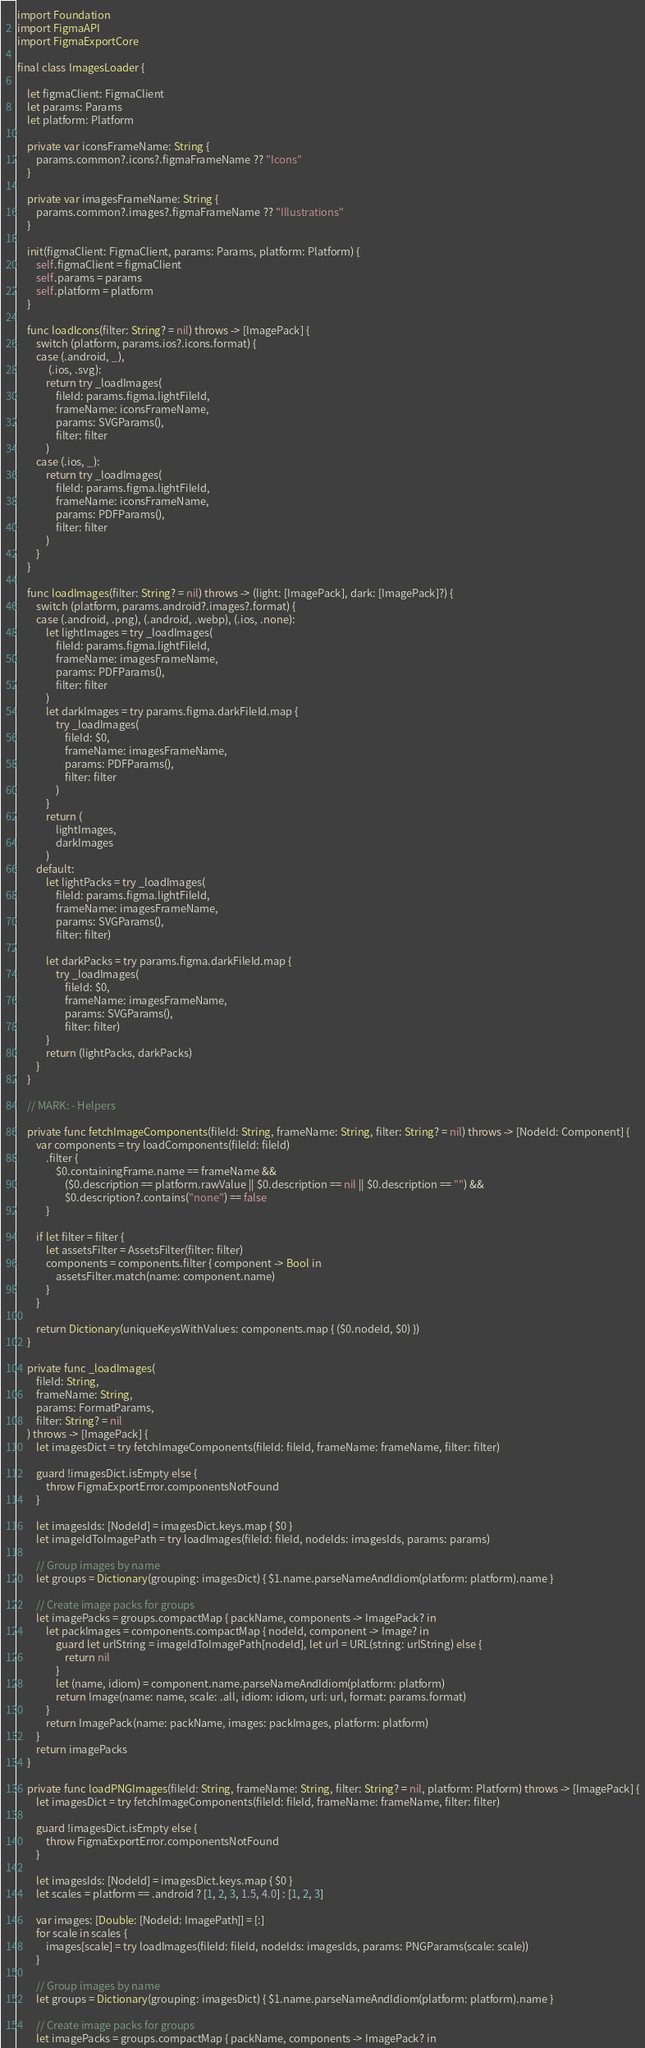<code> <loc_0><loc_0><loc_500><loc_500><_Swift_>import Foundation
import FigmaAPI
import FigmaExportCore

final class ImagesLoader {

    let figmaClient: FigmaClient
    let params: Params
    let platform: Platform
    
    private var iconsFrameName: String {
        params.common?.icons?.figmaFrameName ?? "Icons"
    }
    
    private var imagesFrameName: String {
        params.common?.images?.figmaFrameName ?? "Illustrations"
    }
    
    init(figmaClient: FigmaClient, params: Params, platform: Platform) {
        self.figmaClient = figmaClient
        self.params = params
        self.platform = platform
    }

    func loadIcons(filter: String? = nil) throws -> [ImagePack] {
        switch (platform, params.ios?.icons.format) {
        case (.android, _),
             (.ios, .svg):
            return try _loadImages(
                fileId: params.figma.lightFileId,
                frameName: iconsFrameName,
                params: SVGParams(),
                filter: filter
            )
        case (.ios, _):
            return try _loadImages(
                fileId: params.figma.lightFileId,
                frameName: iconsFrameName,
                params: PDFParams(),
                filter: filter
            )
        }
    }

    func loadImages(filter: String? = nil) throws -> (light: [ImagePack], dark: [ImagePack]?) {
        switch (platform, params.android?.images?.format) {
        case (.android, .png), (.android, .webp), (.ios, .none):
            let lightImages = try _loadImages(
                fileId: params.figma.lightFileId,
                frameName: imagesFrameName,
                params: PDFParams(),
                filter: filter
            )
            let darkImages = try params.figma.darkFileId.map {
                try _loadImages(
                    fileId: $0,
                    frameName: imagesFrameName,
                    params: PDFParams(),
                    filter: filter
                )
            }
            return (
                lightImages,
                darkImages
            )
        default:
            let lightPacks = try _loadImages(
                fileId: params.figma.lightFileId,
                frameName: imagesFrameName,
                params: SVGParams(),
                filter: filter)
            
            let darkPacks = try params.figma.darkFileId.map {
                try _loadImages(
                    fileId: $0,
                    frameName: imagesFrameName,
                    params: SVGParams(),
                    filter: filter)
            }
            return (lightPacks, darkPacks)
        }
    }

    // MARK: - Helpers

    private func fetchImageComponents(fileId: String, frameName: String, filter: String? = nil) throws -> [NodeId: Component] {
        var components = try loadComponents(fileId: fileId)
            .filter {
                $0.containingFrame.name == frameName &&
                    ($0.description == platform.rawValue || $0.description == nil || $0.description == "") &&
                    $0.description?.contains("none") == false
            }
        
        if let filter = filter {
            let assetsFilter = AssetsFilter(filter: filter)
            components = components.filter { component -> Bool in
                assetsFilter.match(name: component.name)
            }
        }
        
        return Dictionary(uniqueKeysWithValues: components.map { ($0.nodeId, $0) })
    }

    private func _loadImages(
        fileId: String,
        frameName: String,
        params: FormatParams,
        filter: String? = nil
    ) throws -> [ImagePack] {
        let imagesDict = try fetchImageComponents(fileId: fileId, frameName: frameName, filter: filter)
        
        guard !imagesDict.isEmpty else {
            throw FigmaExportError.componentsNotFound
        }
        
        let imagesIds: [NodeId] = imagesDict.keys.map { $0 }
        let imageIdToImagePath = try loadImages(fileId: fileId, nodeIds: imagesIds, params: params)

        // Group images by name
        let groups = Dictionary(grouping: imagesDict) { $1.name.parseNameAndIdiom(platform: platform).name }

        // Create image packs for groups
        let imagePacks = groups.compactMap { packName, components -> ImagePack? in
            let packImages = components.compactMap { nodeId, component -> Image? in
                guard let urlString = imageIdToImagePath[nodeId], let url = URL(string: urlString) else {
                    return nil
                }
                let (name, idiom) = component.name.parseNameAndIdiom(platform: platform)
                return Image(name: name, scale: .all, idiom: idiom, url: url, format: params.format)
            }
            return ImagePack(name: packName, images: packImages, platform: platform)
        }
        return imagePacks
    }

    private func loadPNGImages(fileId: String, frameName: String, filter: String? = nil, platform: Platform) throws -> [ImagePack] {
        let imagesDict = try fetchImageComponents(fileId: fileId, frameName: frameName, filter: filter)
        
        guard !imagesDict.isEmpty else {
            throw FigmaExportError.componentsNotFound
        }

        let imagesIds: [NodeId] = imagesDict.keys.map { $0 }
        let scales = platform == .android ? [1, 2, 3, 1.5, 4.0] : [1, 2, 3]

        var images: [Double: [NodeId: ImagePath]] = [:]
        for scale in scales {
            images[scale] = try loadImages(fileId: fileId, nodeIds: imagesIds, params: PNGParams(scale: scale))
        }

        // Group images by name
        let groups = Dictionary(grouping: imagesDict) { $1.name.parseNameAndIdiom(platform: platform).name }

        // Create image packs for groups
        let imagePacks = groups.compactMap { packName, components -> ImagePack? in</code> 